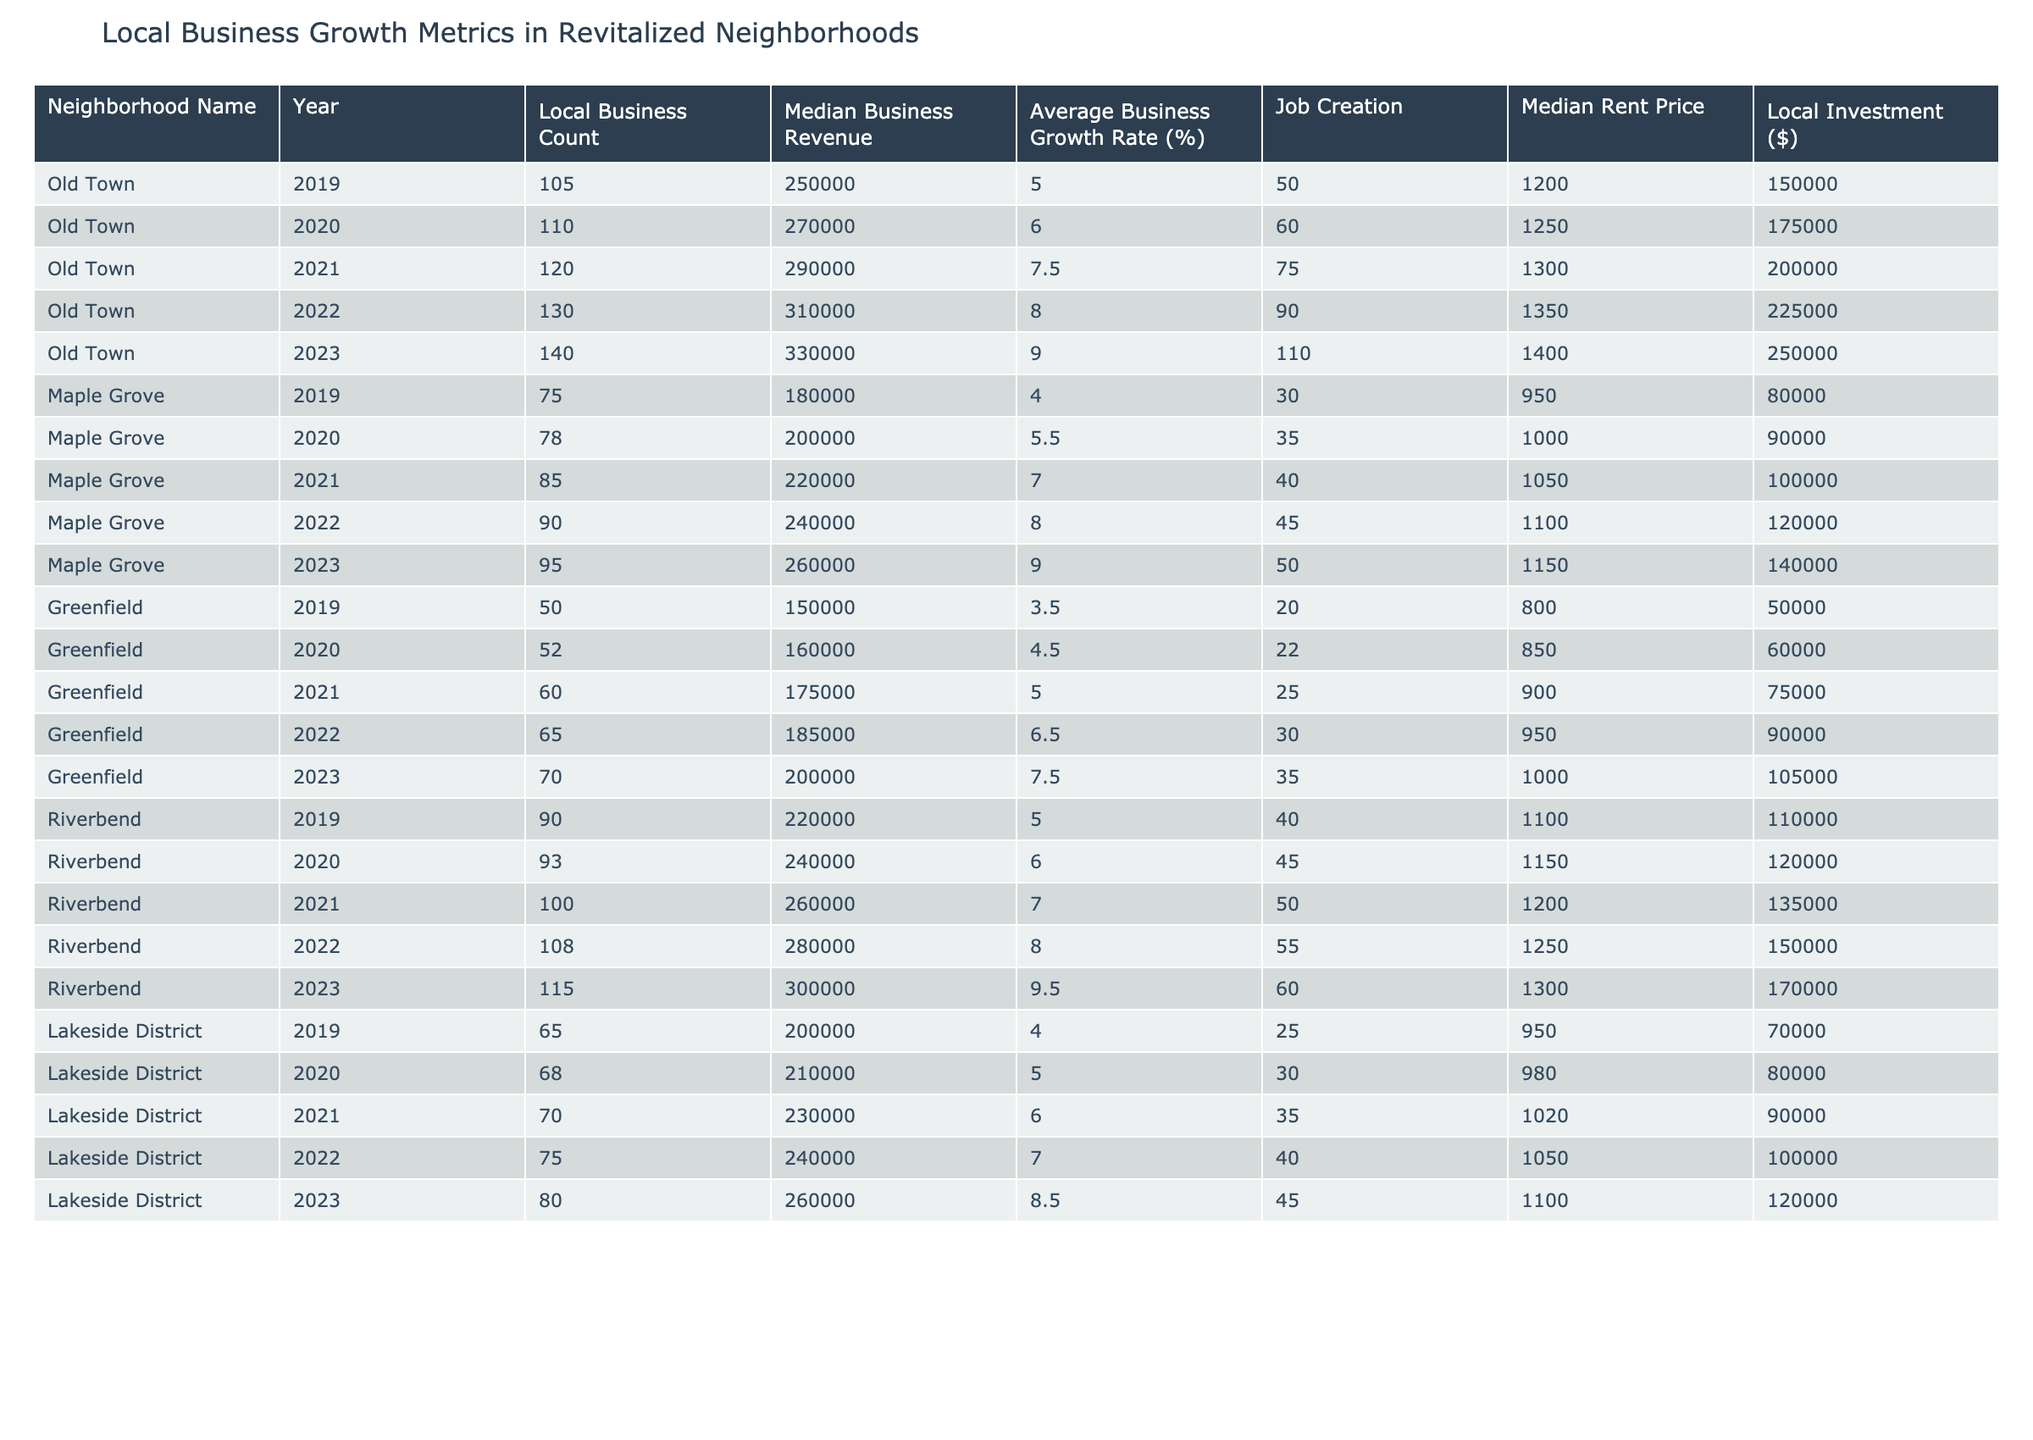What was the median business revenue in Old Town in 2023? According to the table, the median business revenue for Old Town in 2023 is listed directly under that year, which shows a value of 330,000.
Answer: 330,000 How many local businesses were in Maple Grove in 2022? The table specifies that in 2022, Maple Grove had a local business count of 90, as seen in the corresponding row for that neighborhood and year.
Answer: 90 What is the average business growth rate for Riverbend over the last five years? The average business growth rate can be calculated by adding the growth rates for each year from 2019 to 2023 (5.0 + 6.0 + 7.0 + 8.0 + 9.5 = 35.5) and dividing it by 5 years. Therefore, the average is 35.5 / 5 = 7.1%.
Answer: 7.1% Did the job creation in Greenfield increase every year from 2019 to 2023? By examining the job creation values, we find 20 in 2019, 22 in 2020, 25 in 2021, 30 in 2022, and 35 in 2023. Since the job creation number shows a consistent increase each year, the statement is true.
Answer: Yes What was the total local investment in Lakeside District from 2019 to 2023? To find the total local investment, sum the local investment amounts over the years for Lakeside District: 70,000 + 80,000 + 90,000 + 100,000 + 120,000 = 460,000. Therefore, the total local investment over these five years is 460,000.
Answer: 460,000 What was the median rent price in Maple Grove in 2021? Directly from the table, for Maple Grove in 2021, the median rent price is noted as 1,050. This value can be easily retrieved from that year's row.
Answer: 1,050 Did the local business count in Old Town increased by more than 30 percent over the five years? To determine this, we first assess the business count in 2019 (105) and in 2023 (140). The percentage increase can be calculated as ((140 - 105) / 105) * 100 = 33.33%. Thus, it did not exceed 30 percent.
Answer: No What was the average local business count in the neighborhoods over the past five years? To find this, sum the local business counts across all years and neighborhoods: 105 + 110 + 120 + 130 + 140 + 75 + 78 + 85 + 90 + 95 + 50 + 52 + 60 + 65 + 70 + 90 + 93 + 100 + 108 + 115 + 65 + 68 + 70 + 75 + 80 = 1,632. There are 25 data points, so the average is 1,632 / 25 = 65.28.
Answer: 65.28 